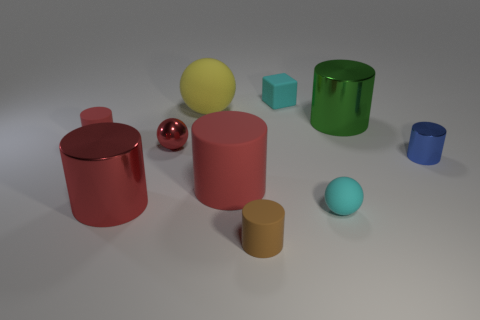How many objects in the image are green, and what are their shapes? In this image, there are two green objects. One is a cylinder with a gleaming, reflective surface, and the other is a cube with a matte texture. Both have distinct shapes and are easily identifiable by their color and form. 